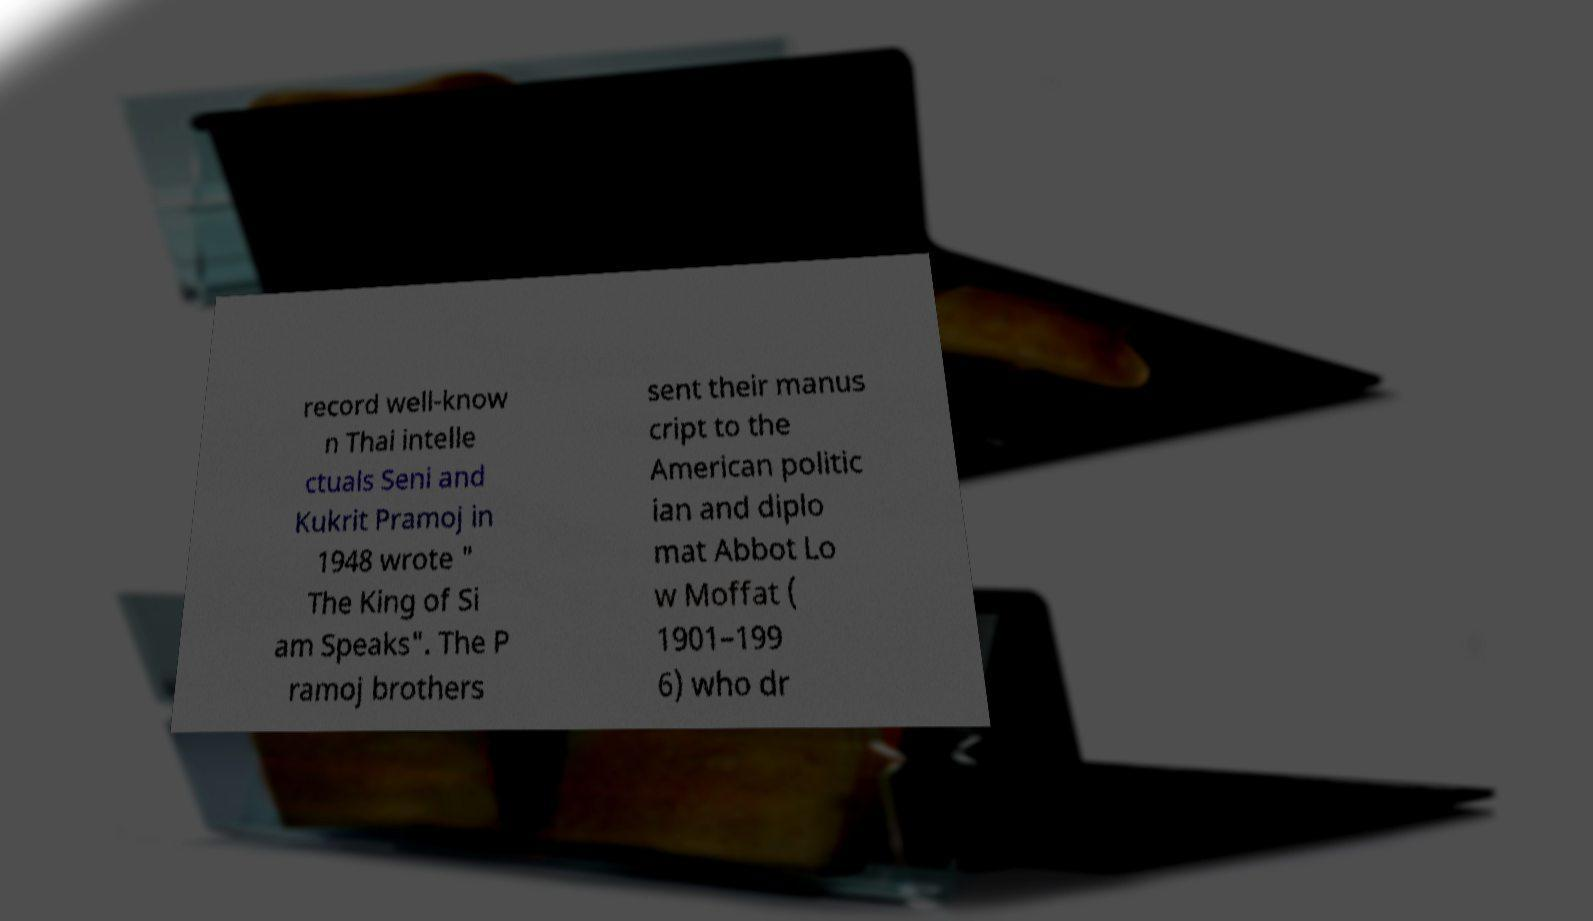What messages or text are displayed in this image? I need them in a readable, typed format. record well-know n Thai intelle ctuals Seni and Kukrit Pramoj in 1948 wrote " The King of Si am Speaks". The P ramoj brothers sent their manus cript to the American politic ian and diplo mat Abbot Lo w Moffat ( 1901–199 6) who dr 